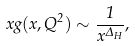Convert formula to latex. <formula><loc_0><loc_0><loc_500><loc_500>x g ( x , Q ^ { 2 } ) \sim \frac { 1 } { x ^ { \Delta _ { H } } } ,</formula> 